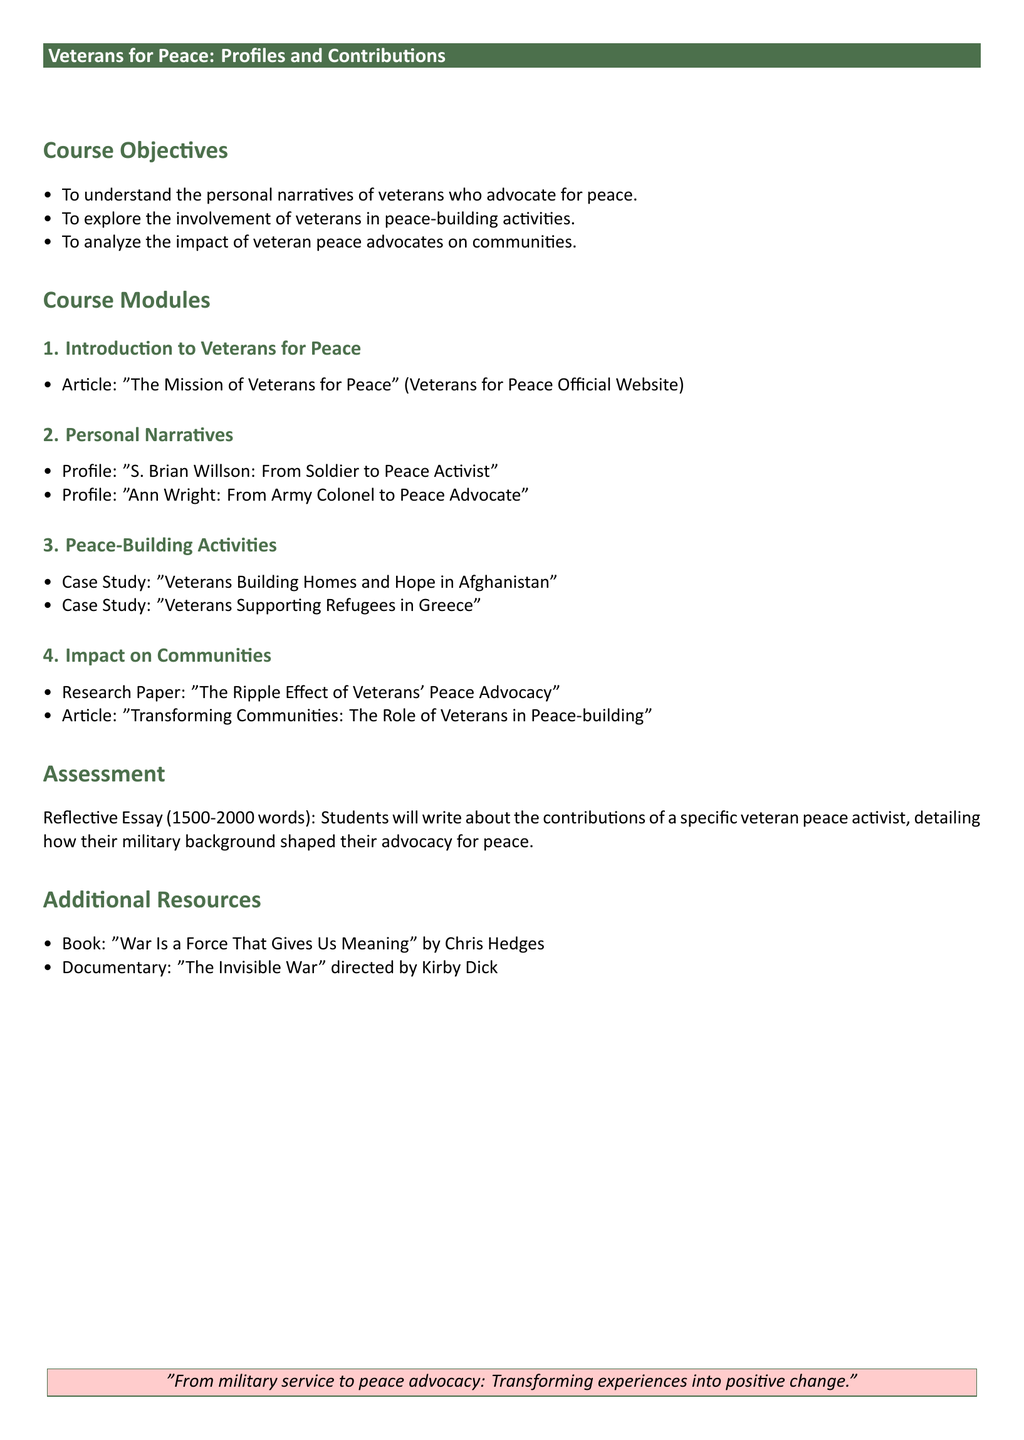What is the title of the syllabus? The title of the syllabus is stated at the beginning of the document within the course header.
Answer: Veterans for Peace: Profiles and Contributions What is the first module about? The first module is titled "Introduction to Veterans for Peace," focusing on an article from the Veterans for Peace Official Website.
Answer: Introduction to Veterans for Peace Who is featured in the profile section? The profile section includes specific names of veterans who have transitioned to peace activism.
Answer: S. Brian Willson and Ann Wright What is the assessment type in the syllabus? The assessment for the course is explicitly mentioned under the Assessment section.
Answer: Reflective Essay How many words should the reflective essay contain? The syllabus specifies the word count for the essay, providing a clear requirement for students.
Answer: 1500-2000 words Which case study focuses on supporting refugees? The case studies are listed under the Peace-Building Activities section, highlighting specific community initiatives.
Answer: Veterans Supporting Refugees in Greece What is the book recommended in Additional Resources? The Additional Resources section lists additional materials for students, including a notable book related to the topic.
Answer: War Is a Force That Gives Us Meaning What are the course objectives? The course objectives are clearly outlined in a bullet point list near the beginning of the document.
Answer: To understand the personal narratives of veterans who advocate for peace What color is used for the course header? The header color is described in the formatting of the document and reflects the overall theme.
Answer: Military green 